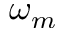Convert formula to latex. <formula><loc_0><loc_0><loc_500><loc_500>\omega _ { m }</formula> 